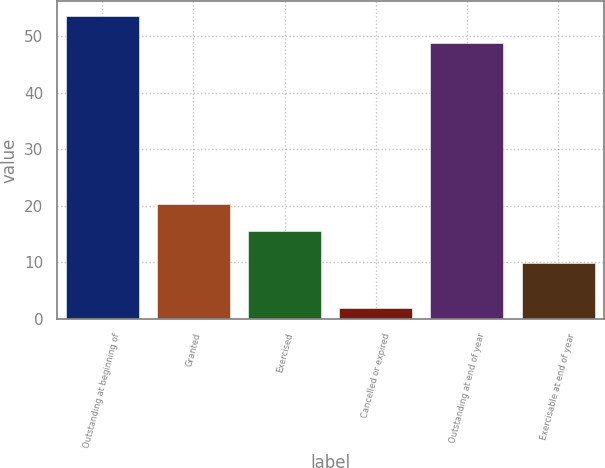<chart> <loc_0><loc_0><loc_500><loc_500><bar_chart><fcel>Outstanding at beginning of<fcel>Granted<fcel>Exercised<fcel>Cancelled or expired<fcel>Outstanding at end of year<fcel>Exercisable at end of year<nl><fcel>53.63<fcel>20.33<fcel>15.6<fcel>2<fcel>48.9<fcel>9.9<nl></chart> 